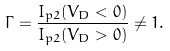Convert formula to latex. <formula><loc_0><loc_0><loc_500><loc_500>\Gamma = \frac { I _ { p 2 } ( V _ { D } < 0 ) } { I _ { p 2 } ( V _ { D } > 0 ) } \neq 1 .</formula> 